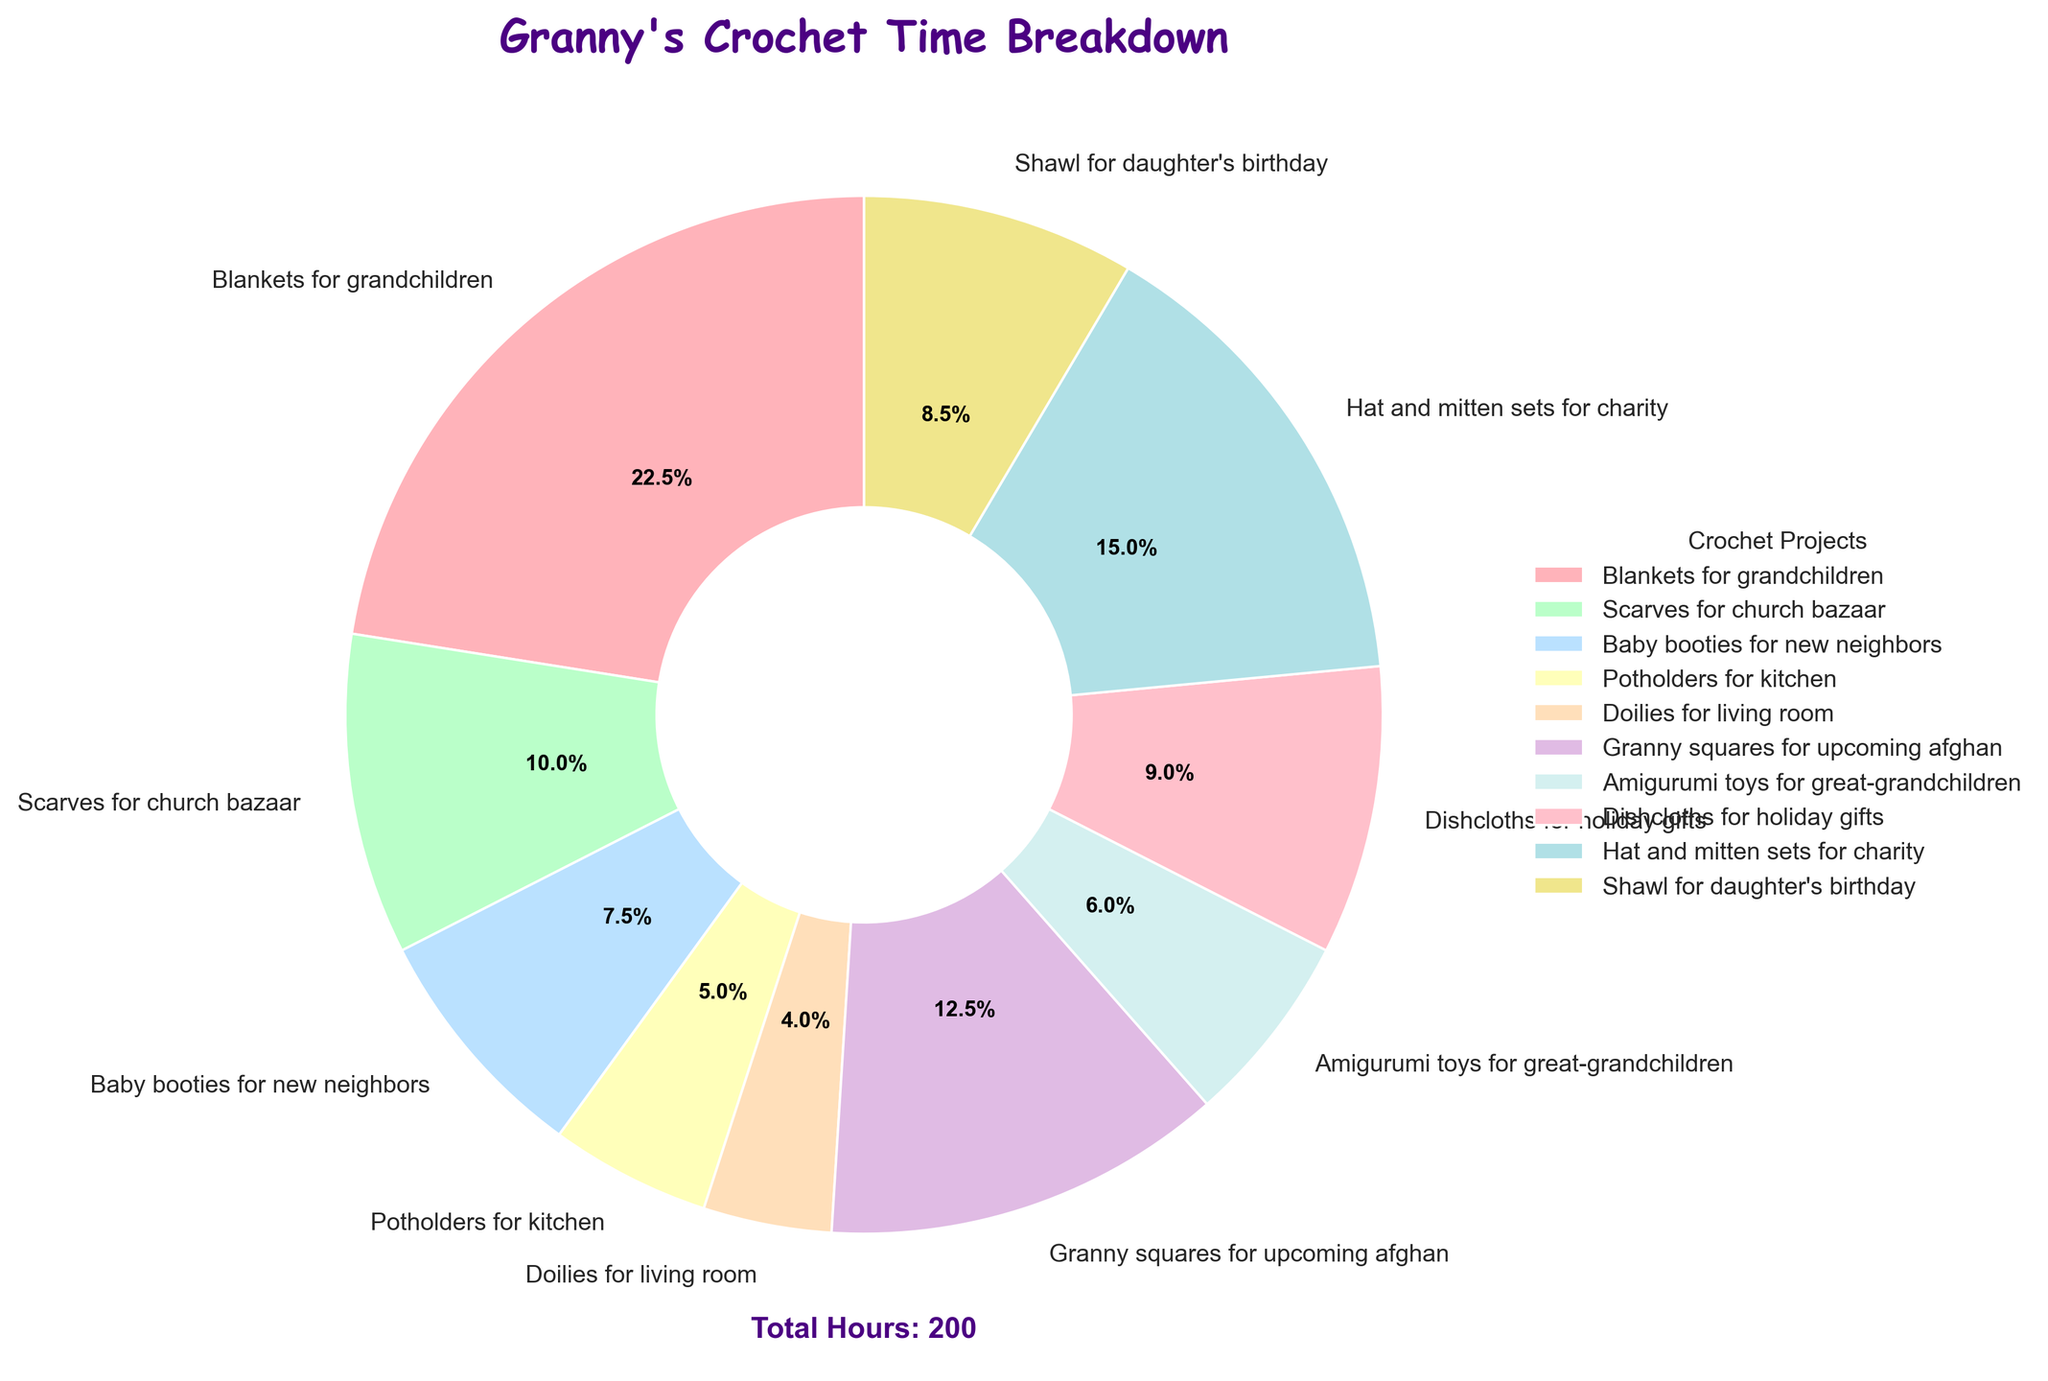Which project takes up the most time? Looking at the pie chart, the section labeled "Blankets for grandchildren" is the largest, indicating it takes up the most time.
Answer: Blankets for grandchildren Which project takes up the least time? Observing the pie chart, the smallest slice corresponds to "Doilies for living room."
Answer: Doilies for living room How much more time is spent on "Hat and mitten sets for charity" compared to "Amigurumi toys for great-grandchildren"? The pie chart shows "Hat and mitten sets for charity" at 30 hours and "Amigurumi toys for great-grandchildren" at 12 hours. The difference is 30 - 12 = 18 hours.
Answer: 18 hours Which projects cumulatively take up more than half of the total time? To find projects taking more than 50% of the total time, sum the hours starting from the largest. "Blankets for grandchildren" (45), "Hat and mitten sets for charity" (30), and "Granny squares for upcoming afghan" (25) give a total of 45 + 30 + 25 = 100 hours out of 200, which is more than half.
Answer: Blankets for grandchildren, Hat and mitten sets for charity, Granny squares for upcoming afghan Are there any two projects that together take up exactly one-quarter of the total time? One-quarter of the total 200 hours is 50 hours. Checking combinations, "Blankets for grandchildren" (45) and "Potholders for kitchen" (10) together make 55 hours, which is not correct. But "Scarves for church bazaar" (20) and "Hat and mitten sets for charity" (30) together make 50 hours.
Answer: Scarves for church bazaar and Hat and mitten sets for charity How much time is spent on all projects related to gifts (Dishcloths, Shawl, and Hat and mitten sets)? Summing the hours of "Dishcloths for holiday gifts" (18), "Shawl for daughter's birthday" (17), and "Hat and mitten sets for charity" (30) gives 18 + 17 + 30 = 65 hours.
Answer: 65 hours Which project related to new neighbors? Inspecting the labels on the pie chart, the project "Baby booties for new neighbors" is identifiable.
Answer: Baby booties for new neighbors Which has a larger share of time, "Granny squares for upcoming afghan" or "Shawl for daughter's birthday"? Comparing their slices, "Granny squares for upcoming afghan" takes 25 hours and "Shawl for daughter's birthday" takes 17 hours. Therefore, "Granny squares" has a larger share of time.
Answer: Granny squares for upcoming afghan 